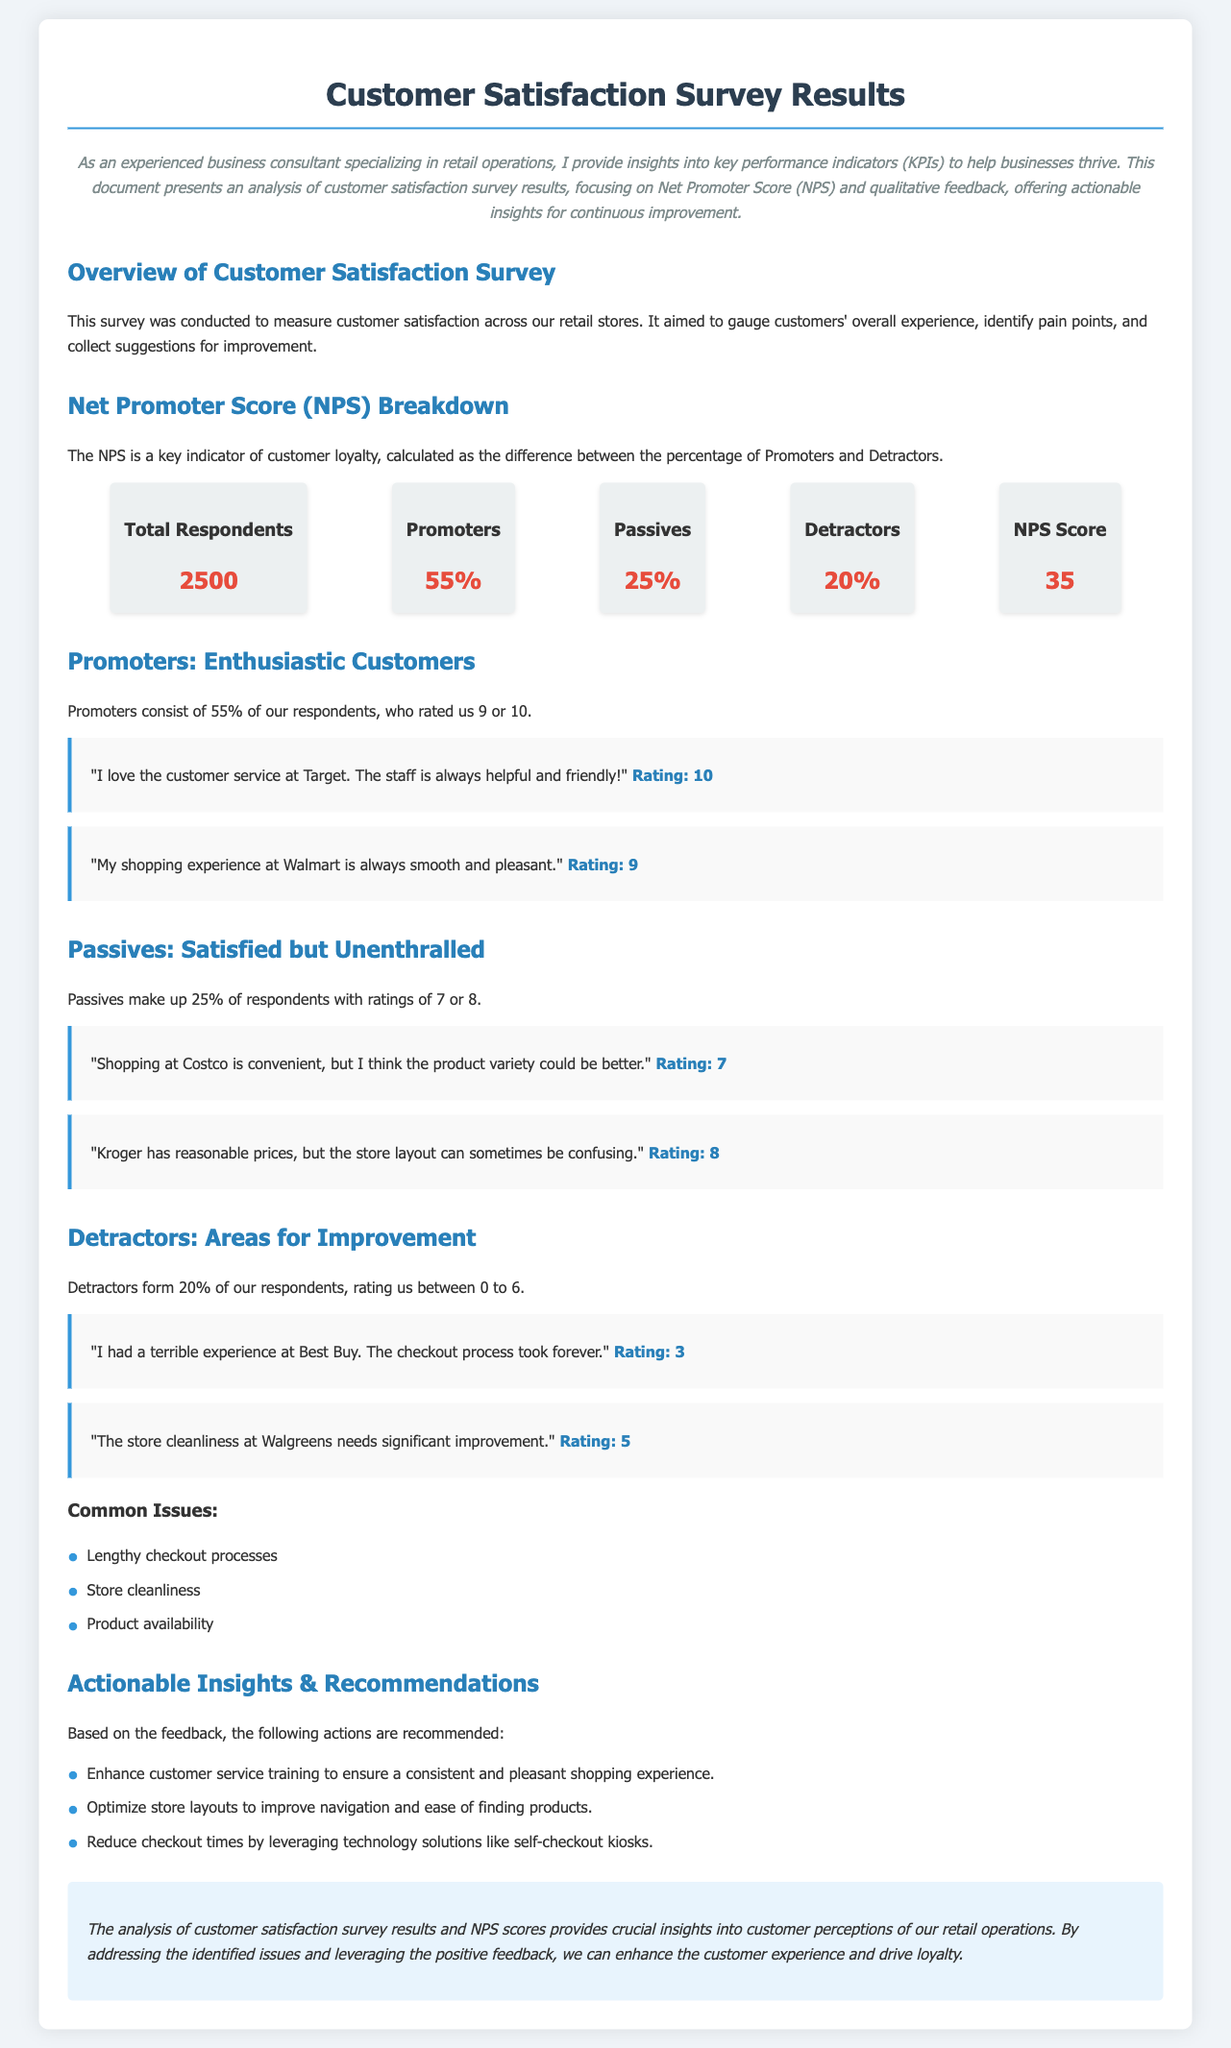What is the total number of respondents? The total number of respondents is stated in the NPS Breakdown section of the document.
Answer: 2500 What percentage of respondents are promoters? The document specifies the percentage of respondents who are classified as promoters.
Answer: 55% What is the NPS score? The NPS score is presented in the NPS Breakdown section as a numerical value.
Answer: 35 What are common issues identified by detractors? The document lists specific common issues mentioned by detractors in their feedback.
Answer: Lengthy checkout processes What action is recommended to enhance customer service? The recommendations in the document suggest enhancing a specific aspect of customer service.
Answer: Enhance customer service training How many feedback comments are provided for promoters? The feedback section for promoters lists the number of comments provided.
Answer: 2 What rating did the customer give for their experience at Best Buy? The document provides the rating a customer gave for their experience at Best Buy as part of the detractor feedback.
Answer: 3 What type of store was mentioned as needing significant improvement in cleanliness? The document specifies a store type that received criticism about cleanliness.
Answer: Walgreens What is the percentage of respondents categorized as passives? The document provides the percentage of respondents classified as passives.
Answer: 25% 